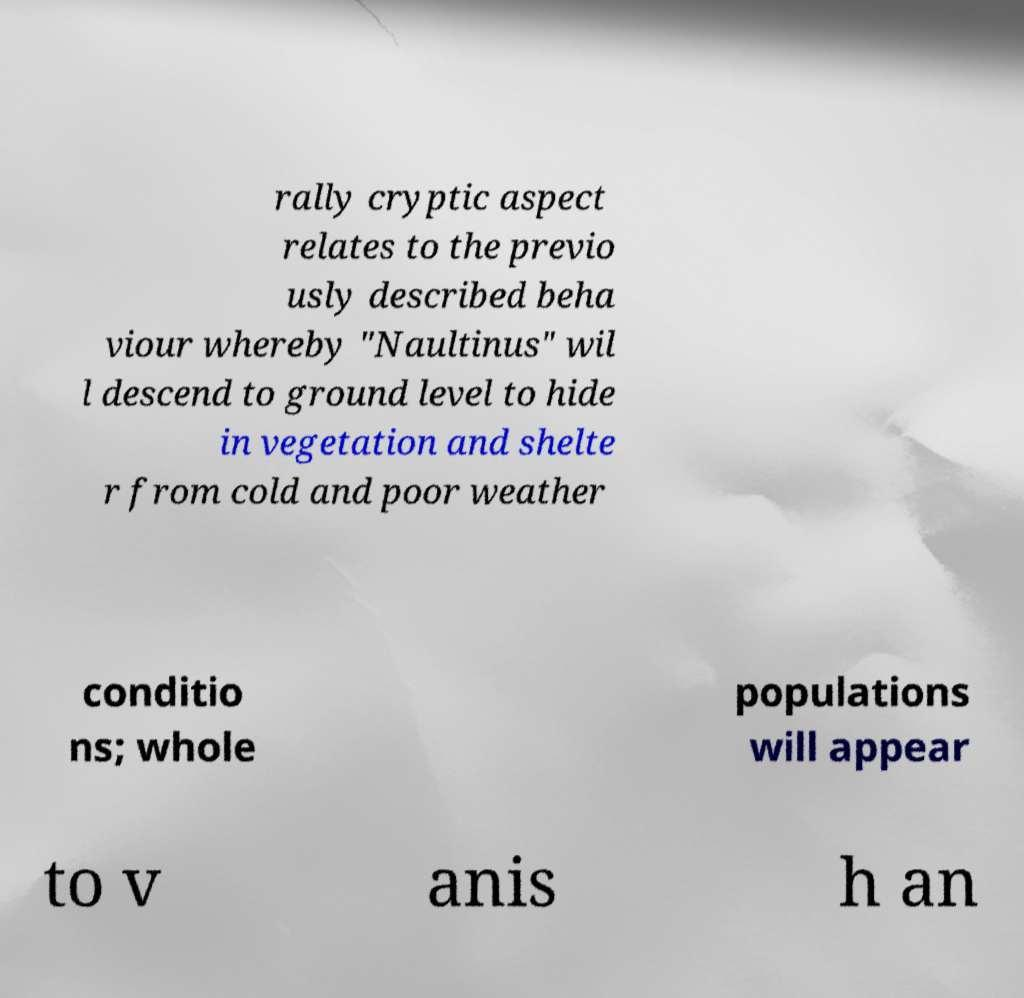Please identify and transcribe the text found in this image. rally cryptic aspect relates to the previo usly described beha viour whereby "Naultinus" wil l descend to ground level to hide in vegetation and shelte r from cold and poor weather conditio ns; whole populations will appear to v anis h an 